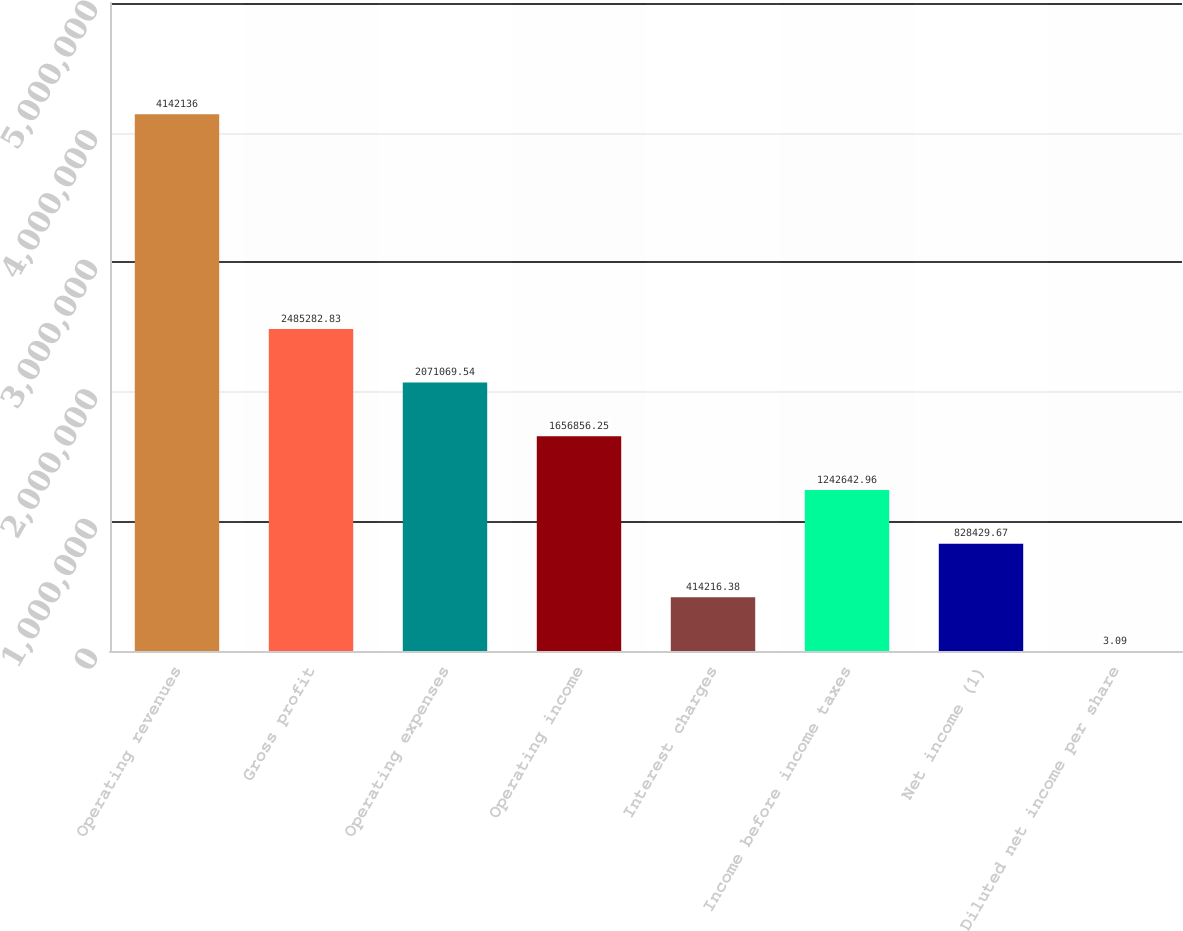Convert chart to OTSL. <chart><loc_0><loc_0><loc_500><loc_500><bar_chart><fcel>Operating revenues<fcel>Gross profit<fcel>Operating expenses<fcel>Operating income<fcel>Interest charges<fcel>Income before income taxes<fcel>Net income (1)<fcel>Diluted net income per share<nl><fcel>4.14214e+06<fcel>2.48528e+06<fcel>2.07107e+06<fcel>1.65686e+06<fcel>414216<fcel>1.24264e+06<fcel>828430<fcel>3.09<nl></chart> 